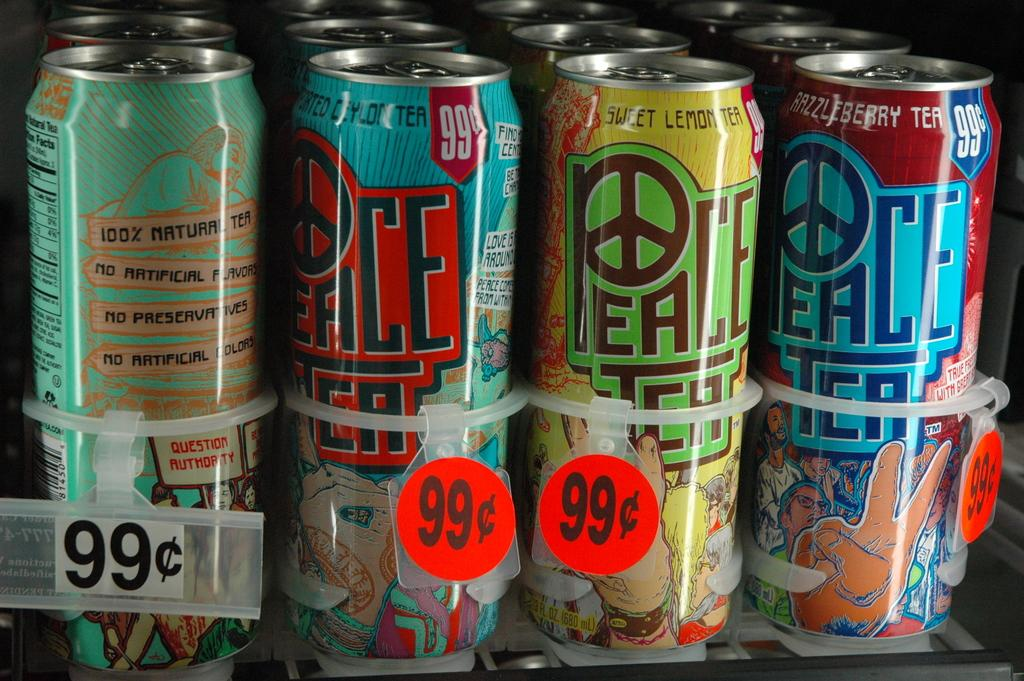Provide a one-sentence caption for the provided image. Different color Peace Tea cans that are 99 cents at a store. 